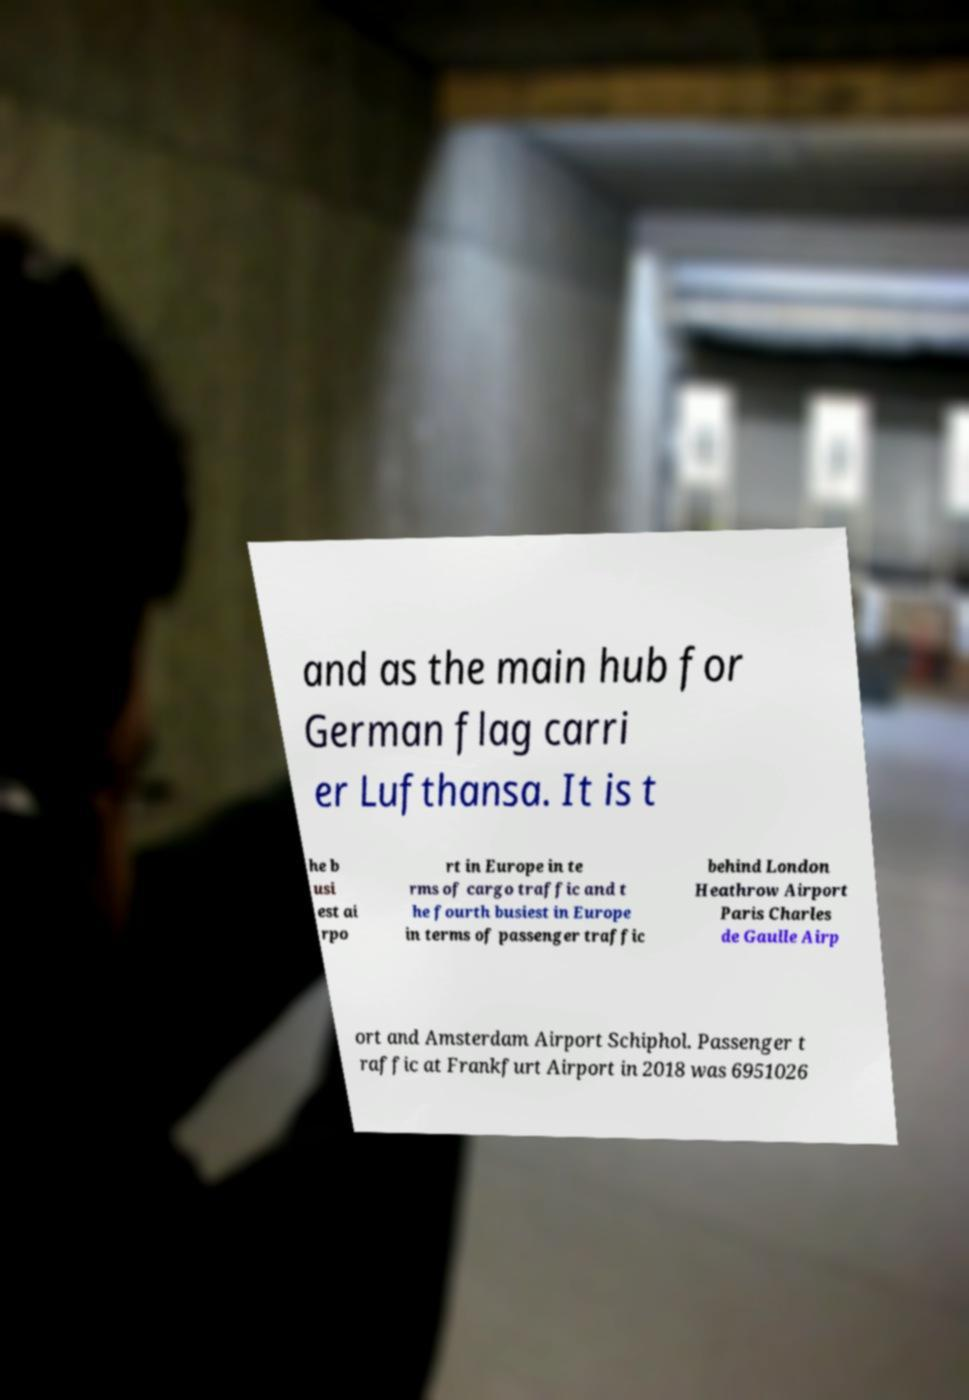For documentation purposes, I need the text within this image transcribed. Could you provide that? and as the main hub for German flag carri er Lufthansa. It is t he b usi est ai rpo rt in Europe in te rms of cargo traffic and t he fourth busiest in Europe in terms of passenger traffic behind London Heathrow Airport Paris Charles de Gaulle Airp ort and Amsterdam Airport Schiphol. Passenger t raffic at Frankfurt Airport in 2018 was 6951026 